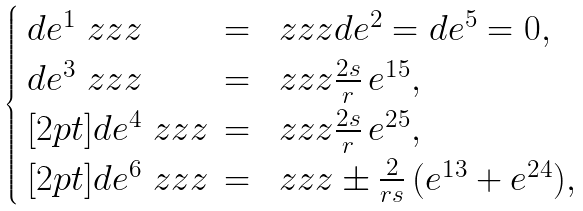<formula> <loc_0><loc_0><loc_500><loc_500>\begin{cases} \begin{array} { l c l } d e ^ { 1 } \ z z z & = & \ z z z d e ^ { 2 } = d e ^ { 5 } = 0 , \\ d e ^ { 3 } \ z z z & = & \ z z z \frac { 2 s } { r } \, e ^ { 1 5 } , \\ [ 2 p t ] d e ^ { 4 } \ z z z & = & \ z z z \frac { 2 s } { r } \, e ^ { 2 5 } , \\ [ 2 p t ] d e ^ { 6 } \ z z z & = & \ z z z \pm \frac { 2 } { r s } \, ( e ^ { 1 3 } + e ^ { 2 4 } ) , \end{array} \end{cases}</formula> 